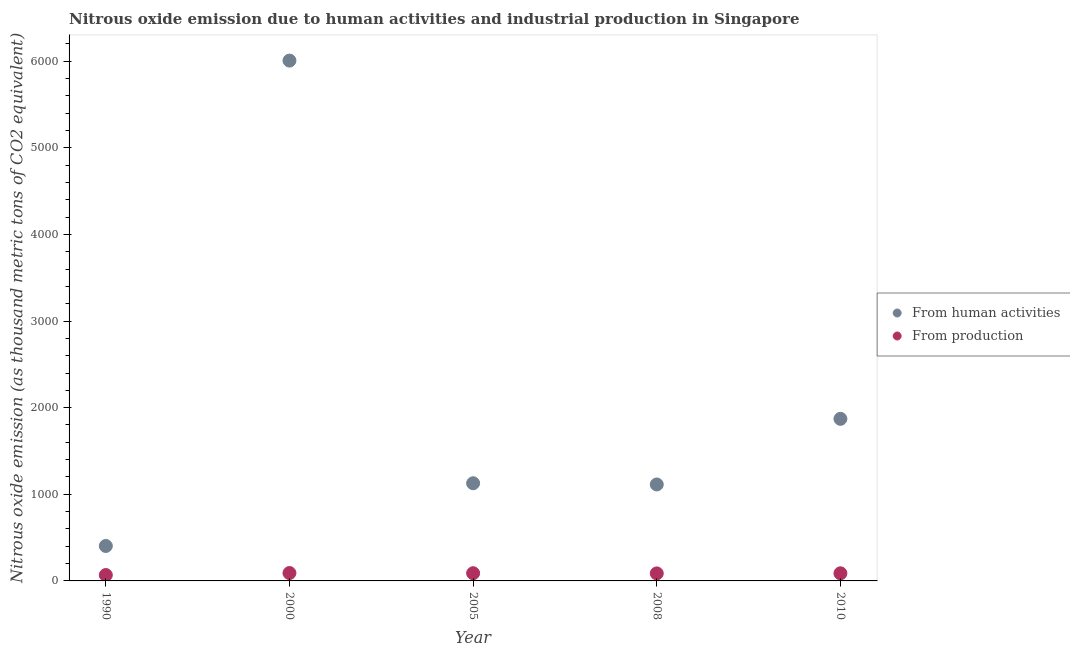How many different coloured dotlines are there?
Give a very brief answer. 2. Is the number of dotlines equal to the number of legend labels?
Your answer should be compact. Yes. What is the amount of emissions generated from industries in 2000?
Offer a terse response. 91.1. Across all years, what is the maximum amount of emissions generated from industries?
Provide a succinct answer. 91.1. Across all years, what is the minimum amount of emissions from human activities?
Make the answer very short. 403.4. In which year was the amount of emissions from human activities maximum?
Your response must be concise. 2000. In which year was the amount of emissions from human activities minimum?
Provide a succinct answer. 1990. What is the total amount of emissions from human activities in the graph?
Keep it short and to the point. 1.05e+04. What is the difference between the amount of emissions generated from industries in 1990 and that in 2010?
Make the answer very short. -20.1. What is the difference between the amount of emissions from human activities in 2010 and the amount of emissions generated from industries in 2005?
Give a very brief answer. 1782.1. What is the average amount of emissions generated from industries per year?
Give a very brief answer. 84.58. In the year 1990, what is the difference between the amount of emissions from human activities and amount of emissions generated from industries?
Offer a very short reply. 335.5. In how many years, is the amount of emissions generated from industries greater than 600 thousand metric tons?
Keep it short and to the point. 0. What is the ratio of the amount of emissions generated from industries in 1990 to that in 2005?
Keep it short and to the point. 0.76. Is the amount of emissions from human activities in 1990 less than that in 2010?
Your answer should be compact. Yes. Is the difference between the amount of emissions from human activities in 2008 and 2010 greater than the difference between the amount of emissions generated from industries in 2008 and 2010?
Give a very brief answer. No. What is the difference between the highest and the second highest amount of emissions generated from industries?
Offer a very short reply. 2.1. What is the difference between the highest and the lowest amount of emissions from human activities?
Make the answer very short. 5603.3. Is the sum of the amount of emissions generated from industries in 2008 and 2010 greater than the maximum amount of emissions from human activities across all years?
Provide a short and direct response. No. Does the amount of emissions generated from industries monotonically increase over the years?
Make the answer very short. No. How many dotlines are there?
Keep it short and to the point. 2. Are the values on the major ticks of Y-axis written in scientific E-notation?
Provide a succinct answer. No. Does the graph contain any zero values?
Offer a terse response. No. Where does the legend appear in the graph?
Your response must be concise. Center right. How are the legend labels stacked?
Provide a succinct answer. Vertical. What is the title of the graph?
Provide a short and direct response. Nitrous oxide emission due to human activities and industrial production in Singapore. What is the label or title of the Y-axis?
Make the answer very short. Nitrous oxide emission (as thousand metric tons of CO2 equivalent). What is the Nitrous oxide emission (as thousand metric tons of CO2 equivalent) of From human activities in 1990?
Ensure brevity in your answer.  403.4. What is the Nitrous oxide emission (as thousand metric tons of CO2 equivalent) of From production in 1990?
Your answer should be very brief. 67.9. What is the Nitrous oxide emission (as thousand metric tons of CO2 equivalent) in From human activities in 2000?
Provide a succinct answer. 6006.7. What is the Nitrous oxide emission (as thousand metric tons of CO2 equivalent) of From production in 2000?
Provide a short and direct response. 91.1. What is the Nitrous oxide emission (as thousand metric tons of CO2 equivalent) in From human activities in 2005?
Offer a very short reply. 1127.5. What is the Nitrous oxide emission (as thousand metric tons of CO2 equivalent) of From production in 2005?
Your answer should be very brief. 89. What is the Nitrous oxide emission (as thousand metric tons of CO2 equivalent) in From human activities in 2008?
Offer a very short reply. 1113.5. What is the Nitrous oxide emission (as thousand metric tons of CO2 equivalent) of From production in 2008?
Your response must be concise. 86.9. What is the Nitrous oxide emission (as thousand metric tons of CO2 equivalent) in From human activities in 2010?
Give a very brief answer. 1871.1. What is the Nitrous oxide emission (as thousand metric tons of CO2 equivalent) in From production in 2010?
Keep it short and to the point. 88. Across all years, what is the maximum Nitrous oxide emission (as thousand metric tons of CO2 equivalent) of From human activities?
Your answer should be very brief. 6006.7. Across all years, what is the maximum Nitrous oxide emission (as thousand metric tons of CO2 equivalent) of From production?
Make the answer very short. 91.1. Across all years, what is the minimum Nitrous oxide emission (as thousand metric tons of CO2 equivalent) in From human activities?
Give a very brief answer. 403.4. Across all years, what is the minimum Nitrous oxide emission (as thousand metric tons of CO2 equivalent) in From production?
Offer a very short reply. 67.9. What is the total Nitrous oxide emission (as thousand metric tons of CO2 equivalent) in From human activities in the graph?
Provide a short and direct response. 1.05e+04. What is the total Nitrous oxide emission (as thousand metric tons of CO2 equivalent) of From production in the graph?
Provide a short and direct response. 422.9. What is the difference between the Nitrous oxide emission (as thousand metric tons of CO2 equivalent) of From human activities in 1990 and that in 2000?
Provide a succinct answer. -5603.3. What is the difference between the Nitrous oxide emission (as thousand metric tons of CO2 equivalent) in From production in 1990 and that in 2000?
Provide a succinct answer. -23.2. What is the difference between the Nitrous oxide emission (as thousand metric tons of CO2 equivalent) in From human activities in 1990 and that in 2005?
Keep it short and to the point. -724.1. What is the difference between the Nitrous oxide emission (as thousand metric tons of CO2 equivalent) in From production in 1990 and that in 2005?
Your answer should be compact. -21.1. What is the difference between the Nitrous oxide emission (as thousand metric tons of CO2 equivalent) of From human activities in 1990 and that in 2008?
Provide a succinct answer. -710.1. What is the difference between the Nitrous oxide emission (as thousand metric tons of CO2 equivalent) in From production in 1990 and that in 2008?
Keep it short and to the point. -19. What is the difference between the Nitrous oxide emission (as thousand metric tons of CO2 equivalent) of From human activities in 1990 and that in 2010?
Give a very brief answer. -1467.7. What is the difference between the Nitrous oxide emission (as thousand metric tons of CO2 equivalent) of From production in 1990 and that in 2010?
Your answer should be very brief. -20.1. What is the difference between the Nitrous oxide emission (as thousand metric tons of CO2 equivalent) of From human activities in 2000 and that in 2005?
Keep it short and to the point. 4879.2. What is the difference between the Nitrous oxide emission (as thousand metric tons of CO2 equivalent) in From production in 2000 and that in 2005?
Your answer should be compact. 2.1. What is the difference between the Nitrous oxide emission (as thousand metric tons of CO2 equivalent) of From human activities in 2000 and that in 2008?
Offer a terse response. 4893.2. What is the difference between the Nitrous oxide emission (as thousand metric tons of CO2 equivalent) in From production in 2000 and that in 2008?
Offer a terse response. 4.2. What is the difference between the Nitrous oxide emission (as thousand metric tons of CO2 equivalent) of From human activities in 2000 and that in 2010?
Offer a very short reply. 4135.6. What is the difference between the Nitrous oxide emission (as thousand metric tons of CO2 equivalent) of From production in 2000 and that in 2010?
Your answer should be compact. 3.1. What is the difference between the Nitrous oxide emission (as thousand metric tons of CO2 equivalent) of From human activities in 2005 and that in 2010?
Ensure brevity in your answer.  -743.6. What is the difference between the Nitrous oxide emission (as thousand metric tons of CO2 equivalent) in From production in 2005 and that in 2010?
Your answer should be very brief. 1. What is the difference between the Nitrous oxide emission (as thousand metric tons of CO2 equivalent) in From human activities in 2008 and that in 2010?
Your answer should be compact. -757.6. What is the difference between the Nitrous oxide emission (as thousand metric tons of CO2 equivalent) of From production in 2008 and that in 2010?
Provide a succinct answer. -1.1. What is the difference between the Nitrous oxide emission (as thousand metric tons of CO2 equivalent) of From human activities in 1990 and the Nitrous oxide emission (as thousand metric tons of CO2 equivalent) of From production in 2000?
Give a very brief answer. 312.3. What is the difference between the Nitrous oxide emission (as thousand metric tons of CO2 equivalent) of From human activities in 1990 and the Nitrous oxide emission (as thousand metric tons of CO2 equivalent) of From production in 2005?
Offer a very short reply. 314.4. What is the difference between the Nitrous oxide emission (as thousand metric tons of CO2 equivalent) of From human activities in 1990 and the Nitrous oxide emission (as thousand metric tons of CO2 equivalent) of From production in 2008?
Make the answer very short. 316.5. What is the difference between the Nitrous oxide emission (as thousand metric tons of CO2 equivalent) of From human activities in 1990 and the Nitrous oxide emission (as thousand metric tons of CO2 equivalent) of From production in 2010?
Keep it short and to the point. 315.4. What is the difference between the Nitrous oxide emission (as thousand metric tons of CO2 equivalent) of From human activities in 2000 and the Nitrous oxide emission (as thousand metric tons of CO2 equivalent) of From production in 2005?
Offer a very short reply. 5917.7. What is the difference between the Nitrous oxide emission (as thousand metric tons of CO2 equivalent) in From human activities in 2000 and the Nitrous oxide emission (as thousand metric tons of CO2 equivalent) in From production in 2008?
Provide a succinct answer. 5919.8. What is the difference between the Nitrous oxide emission (as thousand metric tons of CO2 equivalent) of From human activities in 2000 and the Nitrous oxide emission (as thousand metric tons of CO2 equivalent) of From production in 2010?
Your answer should be compact. 5918.7. What is the difference between the Nitrous oxide emission (as thousand metric tons of CO2 equivalent) of From human activities in 2005 and the Nitrous oxide emission (as thousand metric tons of CO2 equivalent) of From production in 2008?
Offer a very short reply. 1040.6. What is the difference between the Nitrous oxide emission (as thousand metric tons of CO2 equivalent) in From human activities in 2005 and the Nitrous oxide emission (as thousand metric tons of CO2 equivalent) in From production in 2010?
Your answer should be very brief. 1039.5. What is the difference between the Nitrous oxide emission (as thousand metric tons of CO2 equivalent) of From human activities in 2008 and the Nitrous oxide emission (as thousand metric tons of CO2 equivalent) of From production in 2010?
Make the answer very short. 1025.5. What is the average Nitrous oxide emission (as thousand metric tons of CO2 equivalent) of From human activities per year?
Provide a succinct answer. 2104.44. What is the average Nitrous oxide emission (as thousand metric tons of CO2 equivalent) of From production per year?
Keep it short and to the point. 84.58. In the year 1990, what is the difference between the Nitrous oxide emission (as thousand metric tons of CO2 equivalent) in From human activities and Nitrous oxide emission (as thousand metric tons of CO2 equivalent) in From production?
Provide a short and direct response. 335.5. In the year 2000, what is the difference between the Nitrous oxide emission (as thousand metric tons of CO2 equivalent) of From human activities and Nitrous oxide emission (as thousand metric tons of CO2 equivalent) of From production?
Offer a terse response. 5915.6. In the year 2005, what is the difference between the Nitrous oxide emission (as thousand metric tons of CO2 equivalent) of From human activities and Nitrous oxide emission (as thousand metric tons of CO2 equivalent) of From production?
Make the answer very short. 1038.5. In the year 2008, what is the difference between the Nitrous oxide emission (as thousand metric tons of CO2 equivalent) in From human activities and Nitrous oxide emission (as thousand metric tons of CO2 equivalent) in From production?
Offer a very short reply. 1026.6. In the year 2010, what is the difference between the Nitrous oxide emission (as thousand metric tons of CO2 equivalent) of From human activities and Nitrous oxide emission (as thousand metric tons of CO2 equivalent) of From production?
Give a very brief answer. 1783.1. What is the ratio of the Nitrous oxide emission (as thousand metric tons of CO2 equivalent) of From human activities in 1990 to that in 2000?
Your answer should be very brief. 0.07. What is the ratio of the Nitrous oxide emission (as thousand metric tons of CO2 equivalent) in From production in 1990 to that in 2000?
Keep it short and to the point. 0.75. What is the ratio of the Nitrous oxide emission (as thousand metric tons of CO2 equivalent) of From human activities in 1990 to that in 2005?
Your answer should be very brief. 0.36. What is the ratio of the Nitrous oxide emission (as thousand metric tons of CO2 equivalent) in From production in 1990 to that in 2005?
Offer a very short reply. 0.76. What is the ratio of the Nitrous oxide emission (as thousand metric tons of CO2 equivalent) of From human activities in 1990 to that in 2008?
Give a very brief answer. 0.36. What is the ratio of the Nitrous oxide emission (as thousand metric tons of CO2 equivalent) of From production in 1990 to that in 2008?
Offer a terse response. 0.78. What is the ratio of the Nitrous oxide emission (as thousand metric tons of CO2 equivalent) of From human activities in 1990 to that in 2010?
Provide a succinct answer. 0.22. What is the ratio of the Nitrous oxide emission (as thousand metric tons of CO2 equivalent) of From production in 1990 to that in 2010?
Offer a very short reply. 0.77. What is the ratio of the Nitrous oxide emission (as thousand metric tons of CO2 equivalent) of From human activities in 2000 to that in 2005?
Your answer should be compact. 5.33. What is the ratio of the Nitrous oxide emission (as thousand metric tons of CO2 equivalent) of From production in 2000 to that in 2005?
Give a very brief answer. 1.02. What is the ratio of the Nitrous oxide emission (as thousand metric tons of CO2 equivalent) in From human activities in 2000 to that in 2008?
Your answer should be compact. 5.39. What is the ratio of the Nitrous oxide emission (as thousand metric tons of CO2 equivalent) in From production in 2000 to that in 2008?
Give a very brief answer. 1.05. What is the ratio of the Nitrous oxide emission (as thousand metric tons of CO2 equivalent) in From human activities in 2000 to that in 2010?
Keep it short and to the point. 3.21. What is the ratio of the Nitrous oxide emission (as thousand metric tons of CO2 equivalent) of From production in 2000 to that in 2010?
Offer a very short reply. 1.04. What is the ratio of the Nitrous oxide emission (as thousand metric tons of CO2 equivalent) of From human activities in 2005 to that in 2008?
Your answer should be very brief. 1.01. What is the ratio of the Nitrous oxide emission (as thousand metric tons of CO2 equivalent) in From production in 2005 to that in 2008?
Your answer should be compact. 1.02. What is the ratio of the Nitrous oxide emission (as thousand metric tons of CO2 equivalent) in From human activities in 2005 to that in 2010?
Ensure brevity in your answer.  0.6. What is the ratio of the Nitrous oxide emission (as thousand metric tons of CO2 equivalent) of From production in 2005 to that in 2010?
Make the answer very short. 1.01. What is the ratio of the Nitrous oxide emission (as thousand metric tons of CO2 equivalent) of From human activities in 2008 to that in 2010?
Offer a very short reply. 0.6. What is the ratio of the Nitrous oxide emission (as thousand metric tons of CO2 equivalent) in From production in 2008 to that in 2010?
Provide a succinct answer. 0.99. What is the difference between the highest and the second highest Nitrous oxide emission (as thousand metric tons of CO2 equivalent) of From human activities?
Provide a short and direct response. 4135.6. What is the difference between the highest and the lowest Nitrous oxide emission (as thousand metric tons of CO2 equivalent) of From human activities?
Offer a terse response. 5603.3. What is the difference between the highest and the lowest Nitrous oxide emission (as thousand metric tons of CO2 equivalent) of From production?
Keep it short and to the point. 23.2. 